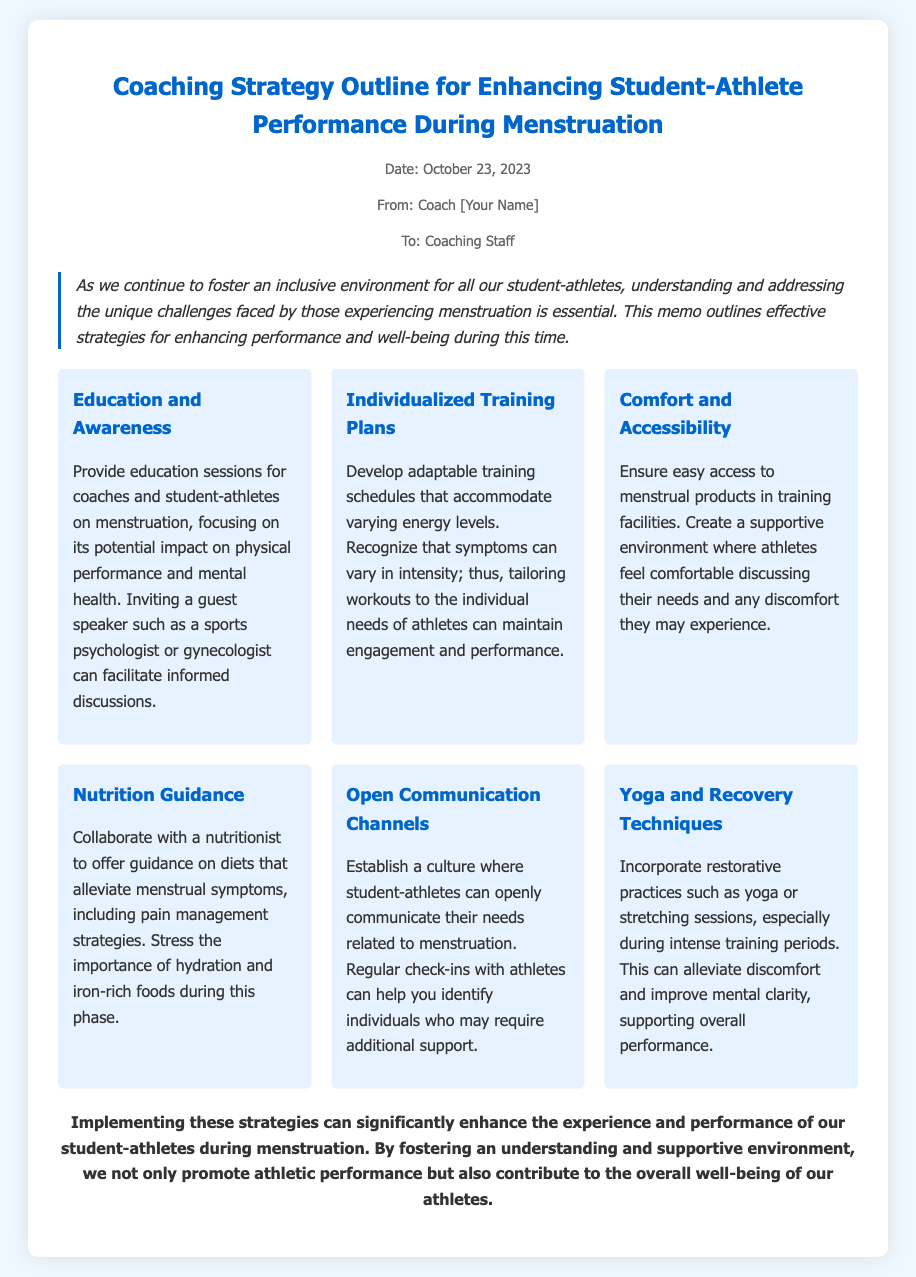What is the date of the memo? The date mentioned in the memo is listed at the top.
Answer: October 23, 2023 Who is the memo addressed to? The memo specifies the recipients in the heading.
Answer: Coaching Staff What is the first strategy outlined in the memo? The strategies are listed in order, and the first one is mentioned in the strategies section.
Answer: Education and Awareness What type of professional is suggested as a guest speaker? The memo refers to specific professionals who can facilitate discussions in the education section.
Answer: Sports psychologist What should be included in individualized training plans? The memo states the focus of training plans in the second strategy section.
Answer: Adaptable training schedules What is the purpose of establishing open communication channels? The memo describes the rationale behind this strategy, focusing on athlete support.
Answer: Identifying individuals who may require additional support What practice is recommended for alleviating discomfort? The memo suggests specific restorative practices in one of the strategies.
Answer: Yoga How should hydration be emphasized? The document mentions hydration in the context of the nutrition guidance strategy.
Answer: Importance of hydration What overall benefit is highlighted in the conclusion? The memo concludes with a summary of the primary benefits discussed.
Answer: Enhance the experience and performance of student-athletes 